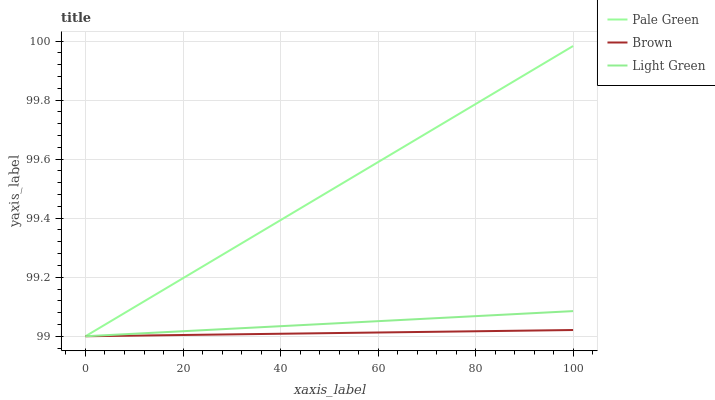Does Brown have the minimum area under the curve?
Answer yes or no. Yes. Does Pale Green have the maximum area under the curve?
Answer yes or no. Yes. Does Light Green have the minimum area under the curve?
Answer yes or no. No. Does Light Green have the maximum area under the curve?
Answer yes or no. No. Is Brown the smoothest?
Answer yes or no. Yes. Is Pale Green the roughest?
Answer yes or no. Yes. Is Light Green the smoothest?
Answer yes or no. No. Is Light Green the roughest?
Answer yes or no. No. Does Pale Green have the highest value?
Answer yes or no. Yes. Does Light Green have the highest value?
Answer yes or no. No. 